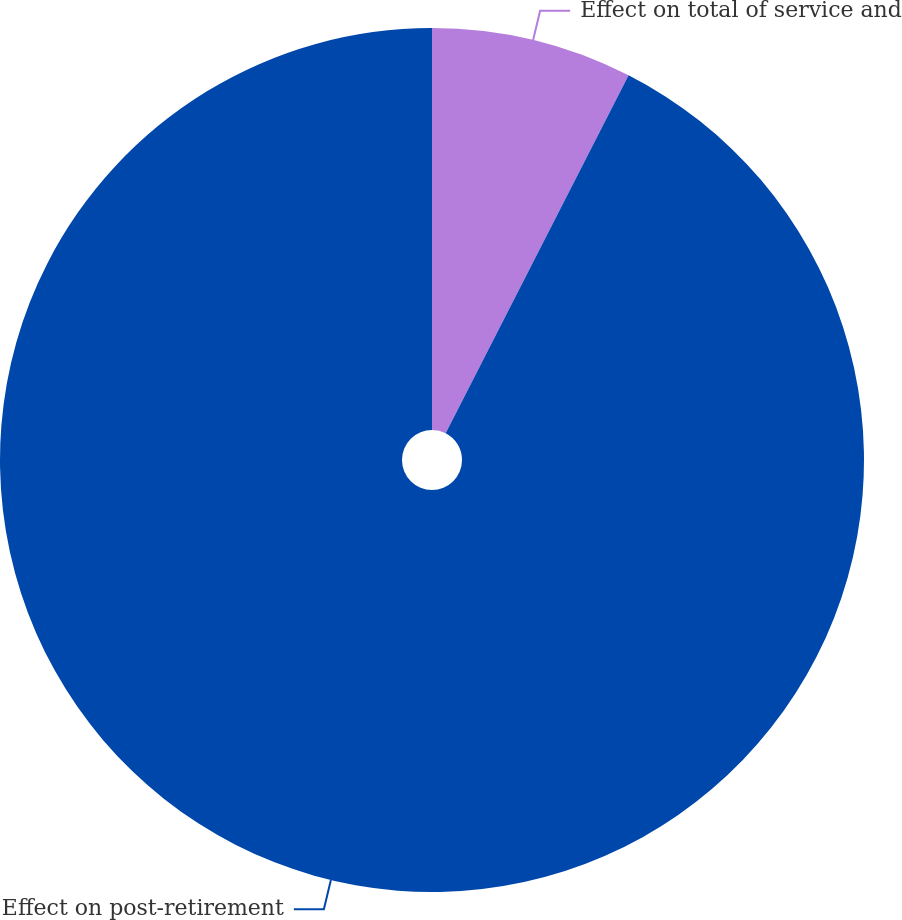Convert chart to OTSL. <chart><loc_0><loc_0><loc_500><loc_500><pie_chart><fcel>Effect on total of service and<fcel>Effect on post-retirement<nl><fcel>7.52%<fcel>92.48%<nl></chart> 